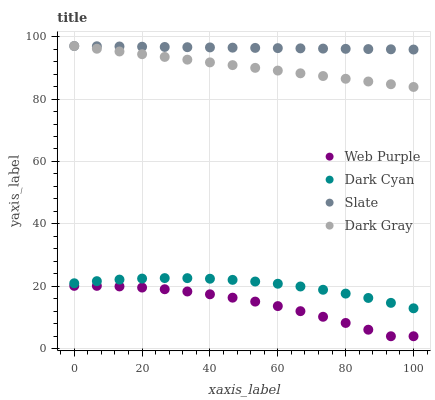Does Web Purple have the minimum area under the curve?
Answer yes or no. Yes. Does Slate have the maximum area under the curve?
Answer yes or no. Yes. Does Dark Gray have the minimum area under the curve?
Answer yes or no. No. Does Dark Gray have the maximum area under the curve?
Answer yes or no. No. Is Dark Gray the smoothest?
Answer yes or no. Yes. Is Web Purple the roughest?
Answer yes or no. Yes. Is Web Purple the smoothest?
Answer yes or no. No. Is Dark Gray the roughest?
Answer yes or no. No. Does Web Purple have the lowest value?
Answer yes or no. Yes. Does Dark Gray have the lowest value?
Answer yes or no. No. Does Slate have the highest value?
Answer yes or no. Yes. Does Web Purple have the highest value?
Answer yes or no. No. Is Dark Cyan less than Dark Gray?
Answer yes or no. Yes. Is Slate greater than Dark Cyan?
Answer yes or no. Yes. Does Dark Gray intersect Slate?
Answer yes or no. Yes. Is Dark Gray less than Slate?
Answer yes or no. No. Is Dark Gray greater than Slate?
Answer yes or no. No. Does Dark Cyan intersect Dark Gray?
Answer yes or no. No. 